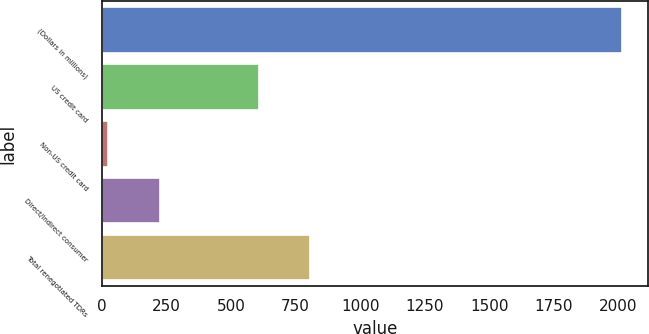Convert chart. <chart><loc_0><loc_0><loc_500><loc_500><bar_chart><fcel>(Dollars in millions)<fcel>US credit card<fcel>Non-US credit card<fcel>Direct/Indirect consumer<fcel>Total renegotiated TDRs<nl><fcel>2013<fcel>607<fcel>26<fcel>224.7<fcel>805.7<nl></chart> 